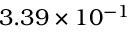Convert formula to latex. <formula><loc_0><loc_0><loc_500><loc_500>3 . 3 9 \times 1 0 ^ { - 1 }</formula> 